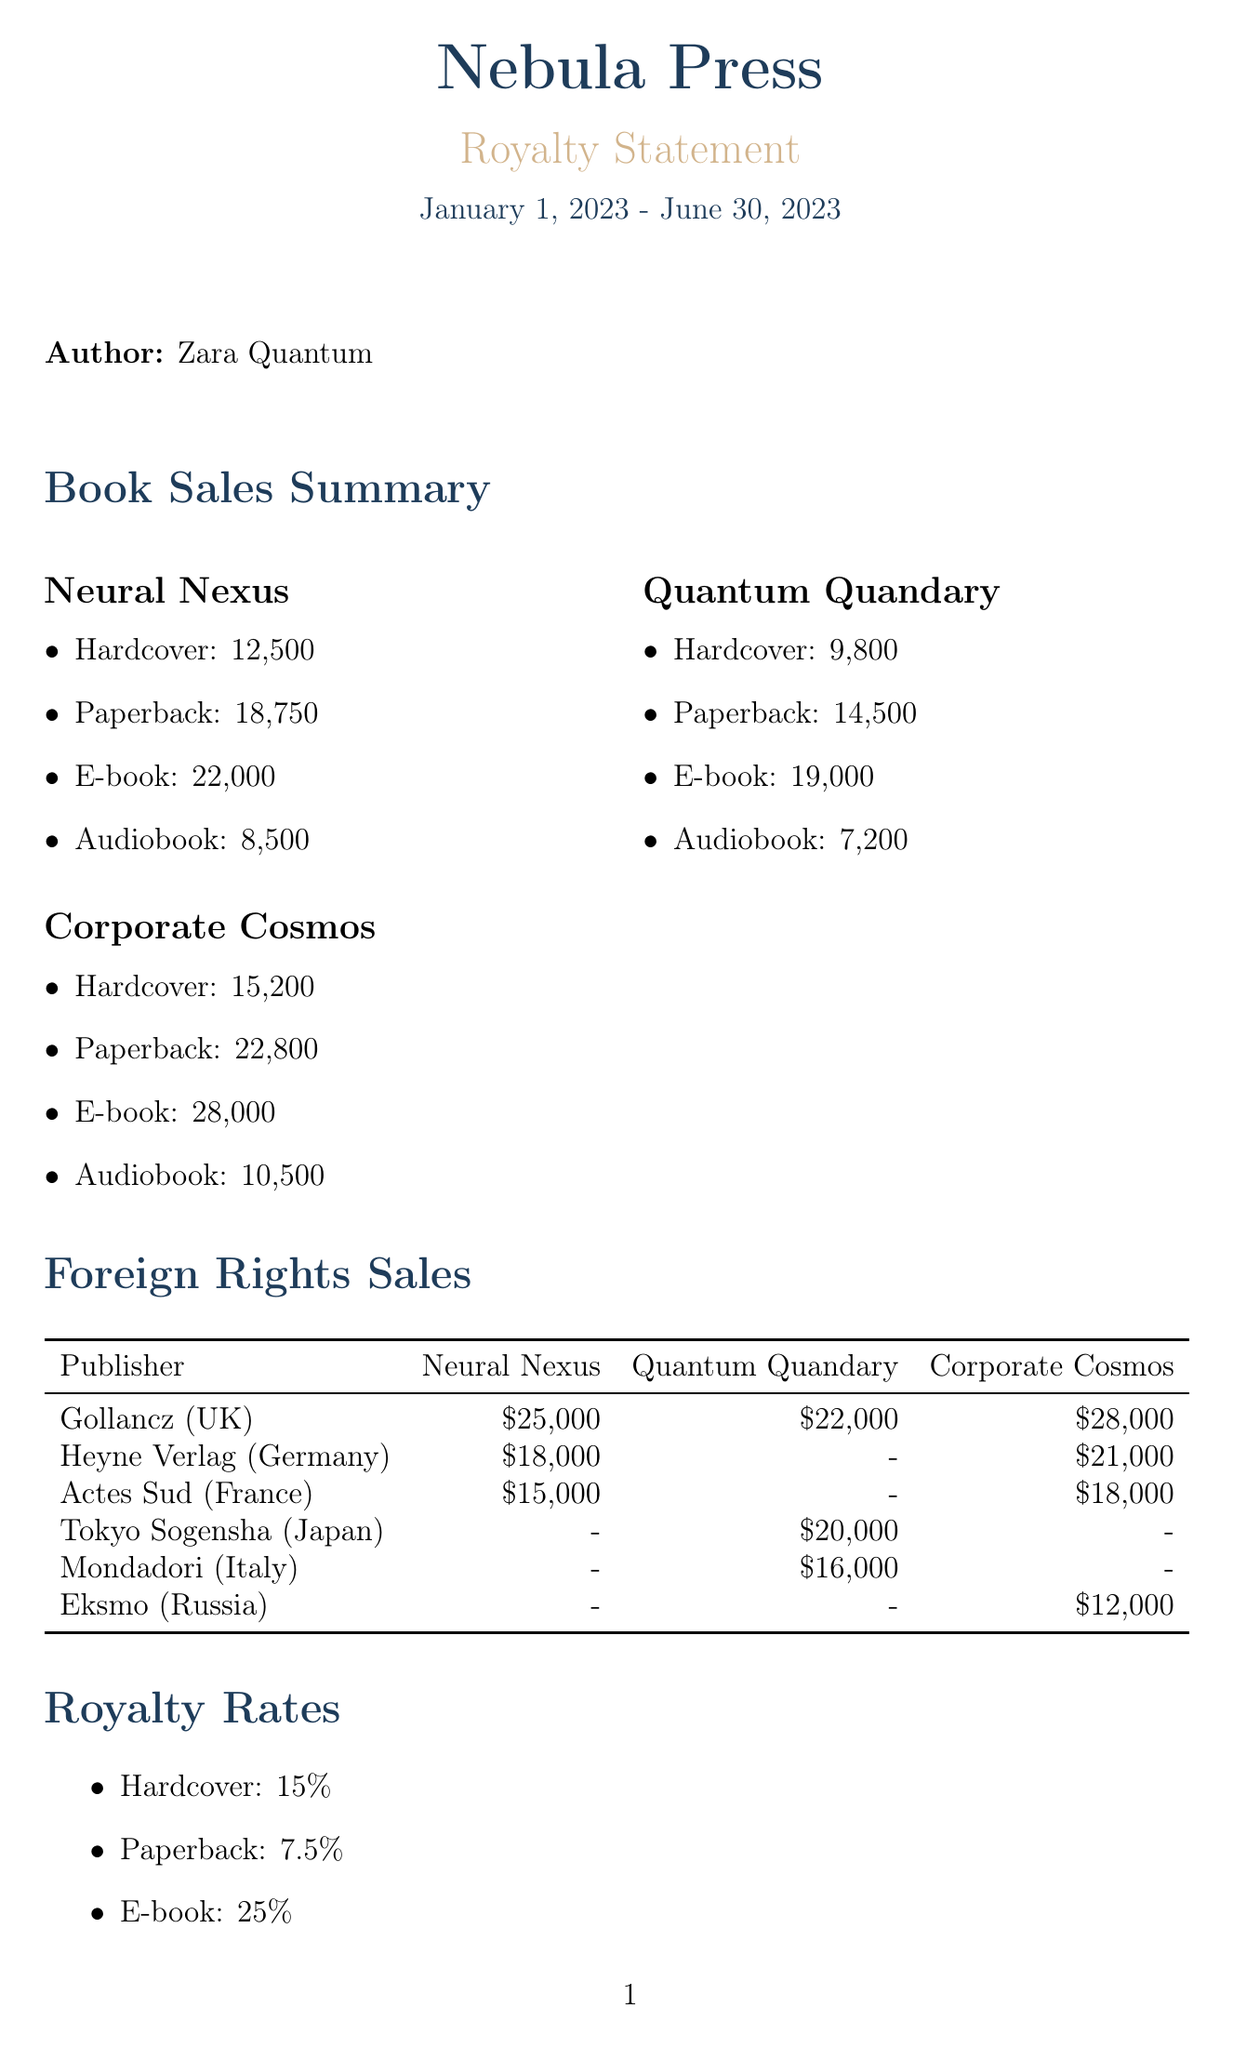What is the publisher's name? The document states that the publisher is Nebula Press.
Answer: Nebula Press What is the total earnings for the reporting period? The total earnings listed in the document is $985,325.
Answer: $985,325 How many major U.S. cities were included in the book tour? The document specifies that the book tour covered 15 major U.S. cities.
Answer: 15 Which book had the highest E-book sales? Comparing the E-book sales, Corporate Cosmos had the highest sales at 28,000.
Answer: Corporate Cosmos What is the royalty rate for E-books? The document states that the royalty rate for E-books is 25%.
Answer: 25% How much was deducted for advances? The document indicates that advance deductions amounted to $150,000.
Answer: $150,000 Which foreign publisher sold rights for 'Quantum Quandary'? The document includes Gollancz (UK) as the foreign publisher for 'Quantum Quandary'.
Answer: Gollancz (UK) What is the upcoming release mentioned in the future projects? The document mentions 'Silicon Singularity' as the upcoming release.
Answer: Silicon Singularity How many global participants attended the virtual reality book launch event? The document notes that 50,000 global participants attended the virtual reality book launch.
Answer: 50,000 